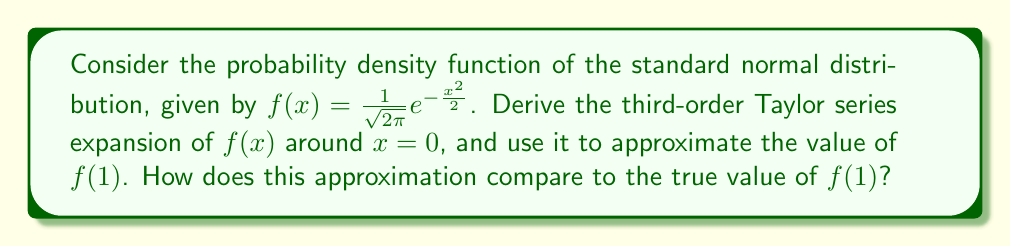Help me with this question. 1) First, we need to calculate the derivatives of $f(x)$ up to the third order:

   $f(x) = \frac{1}{\sqrt{2\pi}}e^{-\frac{x^2}{2}}$
   $f'(x) = -\frac{x}{\sqrt{2\pi}}e^{-\frac{x^2}{2}}$
   $f''(x) = \frac{1}{\sqrt{2\pi}}e^{-\frac{x^2}{2}}(x^2-1)$
   $f'''(x) = \frac{1}{\sqrt{2\pi}}e^{-\frac{x^2}{2}}(-x^3+3x)$

2) The Taylor series expansion around $x=0$ up to the third order is:

   $f(x) \approx f(0) + f'(0)x + \frac{f''(0)}{2!}x^2 + \frac{f'''(0)}{3!}x^3$

3) Evaluate the derivatives at $x=0$:

   $f(0) = \frac{1}{\sqrt{2\pi}}$
   $f'(0) = 0$
   $f''(0) = -\frac{1}{\sqrt{2\pi}}$
   $f'''(0) = 0$

4) Substitute these values into the Taylor series:

   $f(x) \approx \frac{1}{\sqrt{2\pi}} - \frac{1}{2\sqrt{2\pi}}x^2$

5) To approximate $f(1)$, substitute $x=1$:

   $f(1) \approx \frac{1}{\sqrt{2\pi}} - \frac{1}{2\sqrt{2\pi}} = \frac{1}{2\sqrt{2\pi}} \approx 0.1995$

6) The true value of $f(1)$ is:

   $f(1) = \frac{1}{\sqrt{2\pi}}e^{-\frac{1^2}{2}} \approx 0.2420$

7) The relative error of the approximation is:

   $\frac{|0.2420 - 0.1995|}{0.2420} \times 100\% \approx 17.56\%$
Answer: $f(1) \approx 0.1995$, with a relative error of 17.56% 